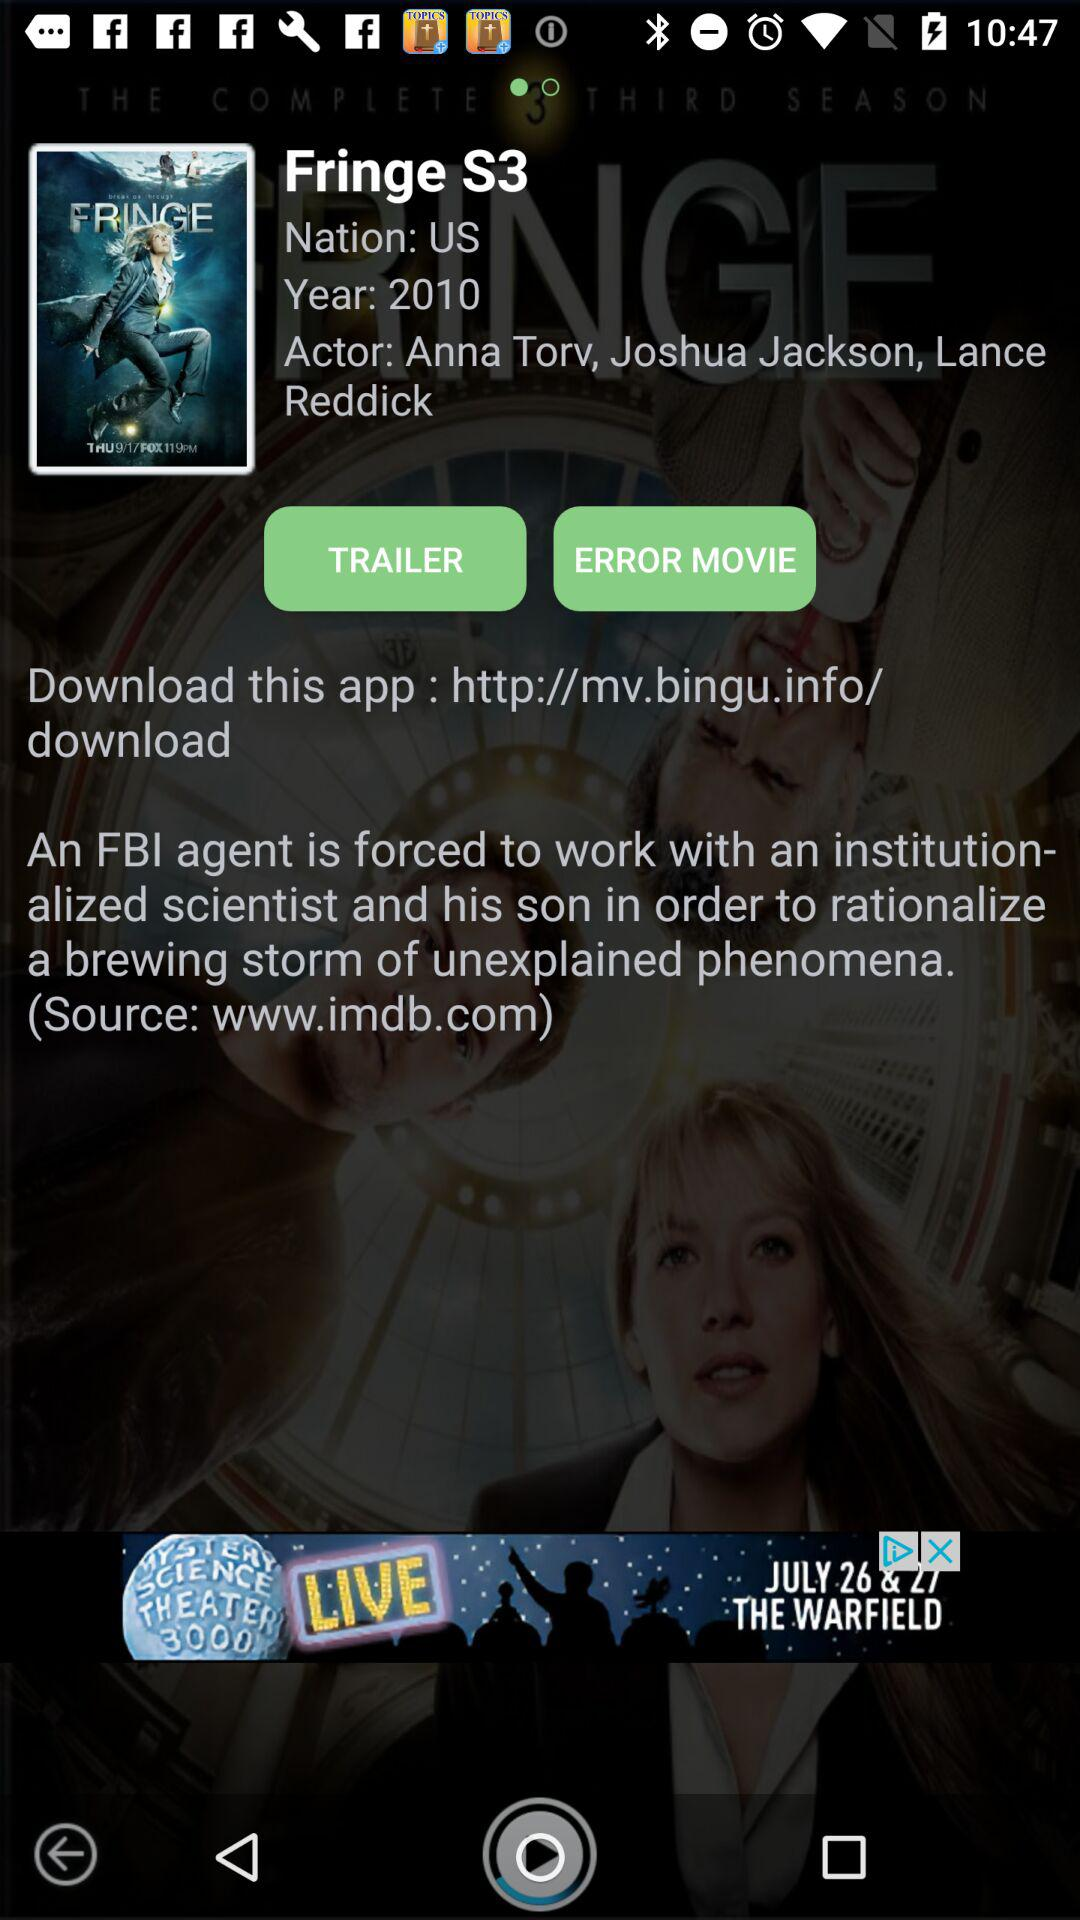In what year was the movie released? The movie was released in 2010. 